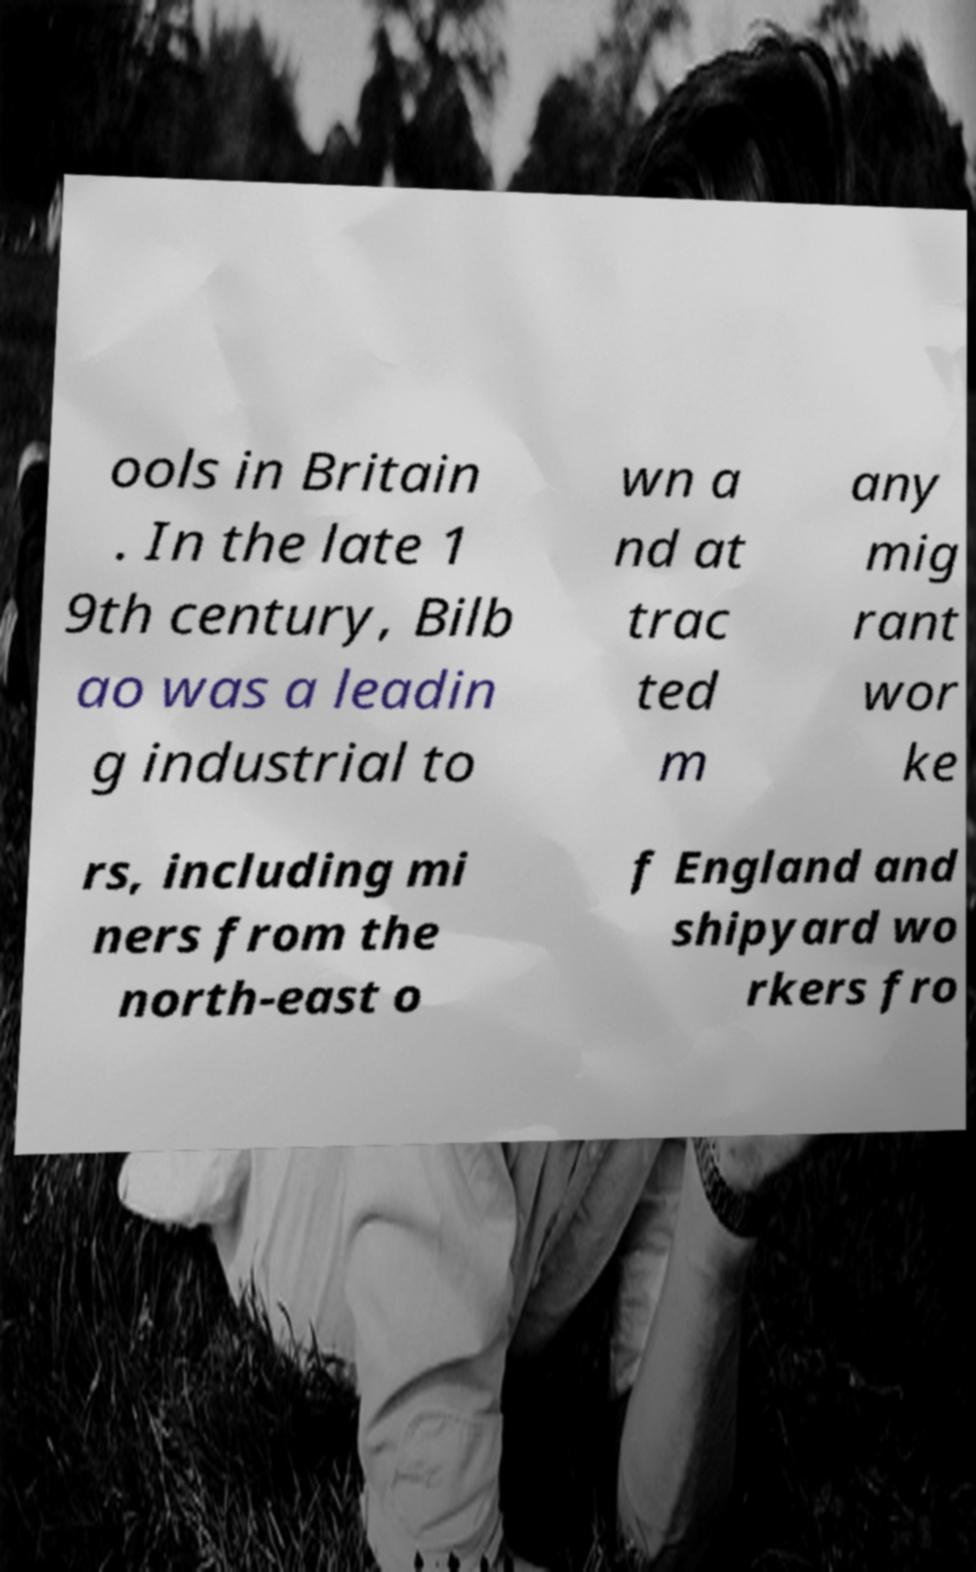Can you accurately transcribe the text from the provided image for me? ools in Britain . In the late 1 9th century, Bilb ao was a leadin g industrial to wn a nd at trac ted m any mig rant wor ke rs, including mi ners from the north-east o f England and shipyard wo rkers fro 